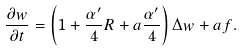Convert formula to latex. <formula><loc_0><loc_0><loc_500><loc_500>\frac { \partial w } { \partial t } = \left ( 1 + \frac { \alpha ^ { \prime } } { 4 } R + a \frac { \alpha ^ { \prime } } { 4 } \right ) \Delta w + a f .</formula> 